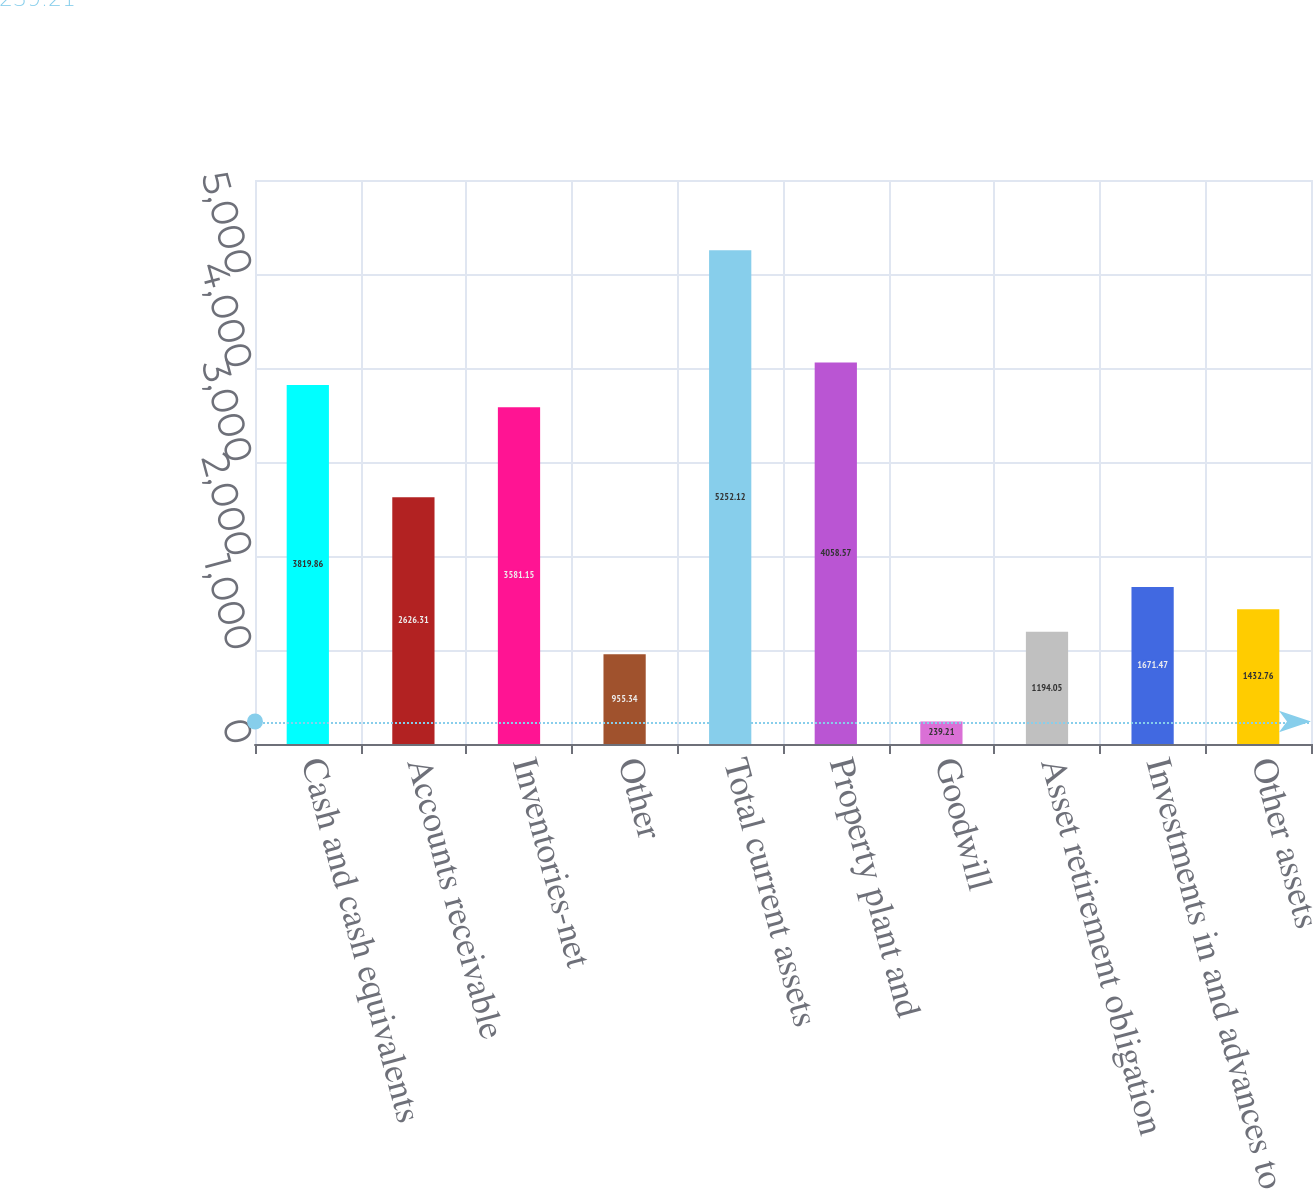Convert chart. <chart><loc_0><loc_0><loc_500><loc_500><bar_chart><fcel>Cash and cash equivalents<fcel>Accounts receivable<fcel>Inventories-net<fcel>Other<fcel>Total current assets<fcel>Property plant and<fcel>Goodwill<fcel>Asset retirement obligation<fcel>Investments in and advances to<fcel>Other assets<nl><fcel>3819.86<fcel>2626.31<fcel>3581.15<fcel>955.34<fcel>5252.12<fcel>4058.57<fcel>239.21<fcel>1194.05<fcel>1671.47<fcel>1432.76<nl></chart> 